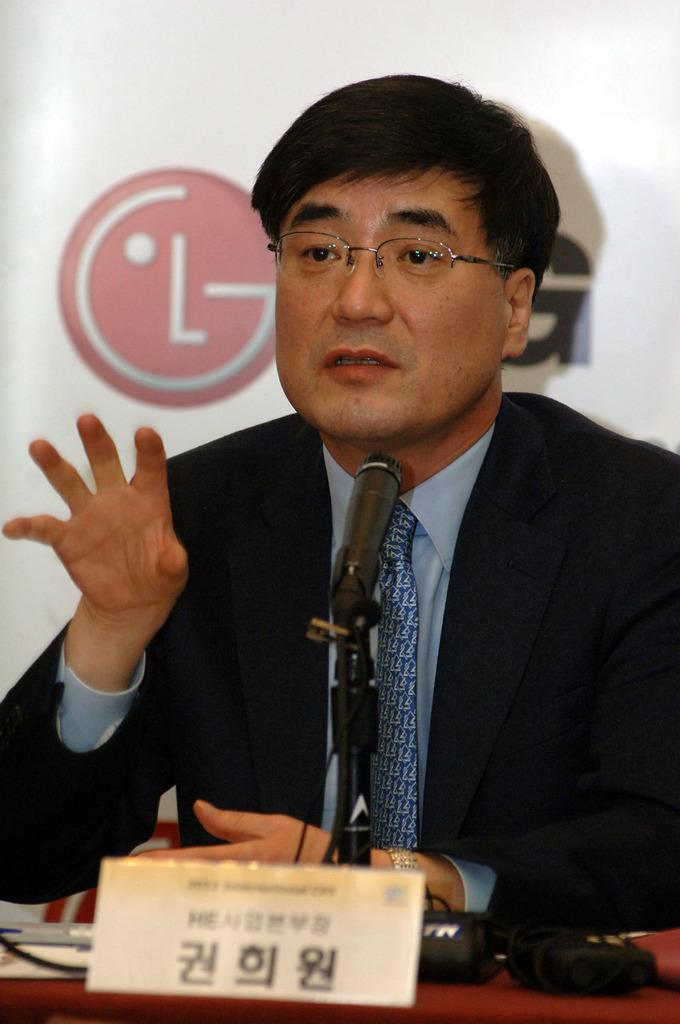Can you describe this image briefly? As we can see in the image there is a man wearing black color jacket and sitting. In front of him there is a table. On table there is a poster and mic. Behind him there is a screen. 